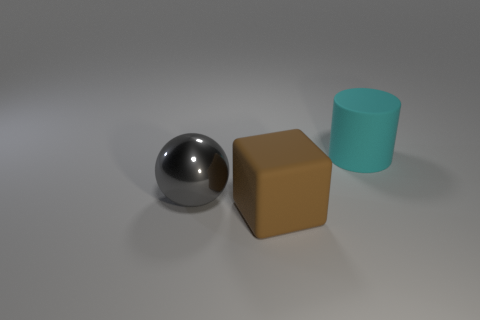There is a matte object that is in front of the gray metal object; is its size the same as the large metal ball?
Offer a terse response. Yes. Is the number of cyan matte things left of the brown block less than the number of large rubber objects to the right of the big rubber cylinder?
Give a very brief answer. No. Is the sphere the same color as the cylinder?
Your answer should be compact. No. Are there fewer large brown blocks in front of the brown rubber object than small gray metal spheres?
Offer a terse response. No. Does the large cube have the same material as the large gray object?
Your answer should be very brief. No. How many balls are the same material as the brown object?
Your response must be concise. 0. The big cube that is made of the same material as the cyan thing is what color?
Offer a terse response. Brown. What shape is the brown object?
Ensure brevity in your answer.  Cube. There is a large object on the right side of the matte block; what material is it?
Ensure brevity in your answer.  Rubber. Are there any big metallic objects that have the same color as the cylinder?
Give a very brief answer. No. 